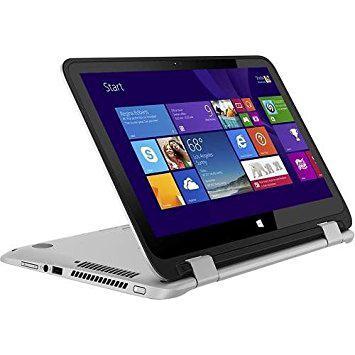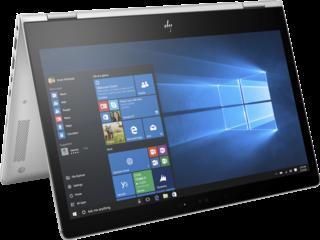The first image is the image on the left, the second image is the image on the right. For the images shown, is this caption "All devices feature screens with images on them." true? Answer yes or no. Yes. 